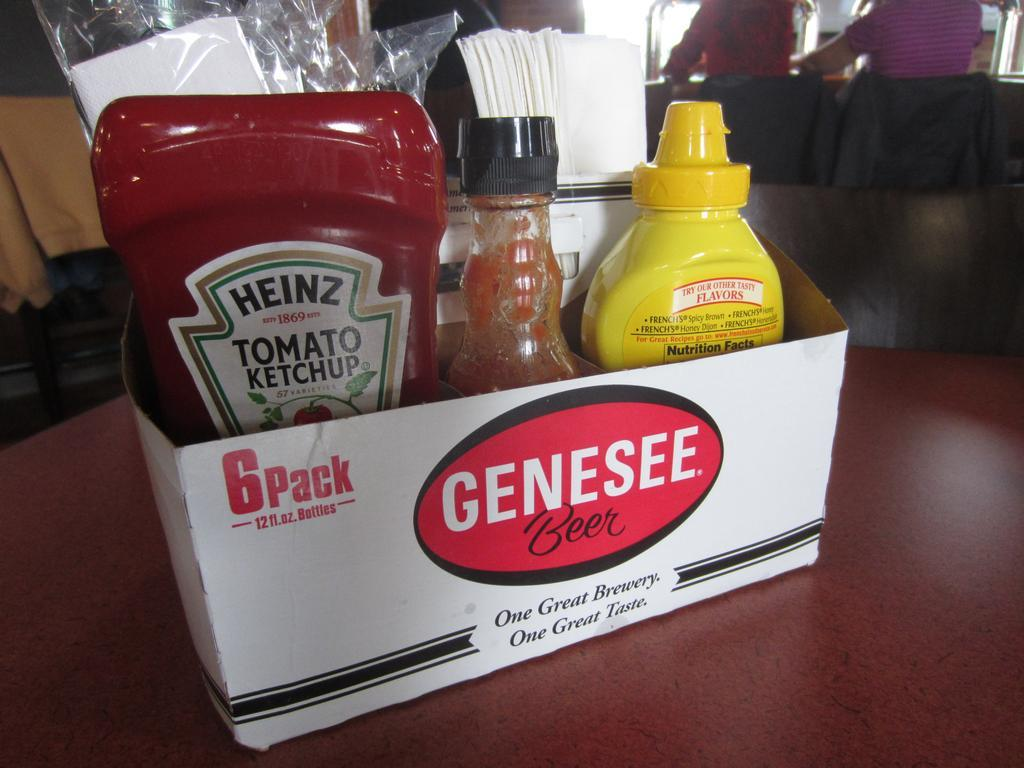Could you describe how the visual branding elements in the image contribute to the marketing of Genesee Beer? The visual branding of Genesee Beer, as seen on the beer caddy, plays a strategic role in marketing within the restaurant setting. The slogan 'One Great Brewery. One Great Taste.' featured prominently on the caddy contributes to brand recall and reinforces Genesee's identity as a key player in the brewery industry. By associating the brand with everyday dining experience through the clever reuse of the beer holder, the restaurant not only promotes Genesee Beer subtly but also enhances its visibility and appeal among the patrons, potentially influencing their beverage choices. 